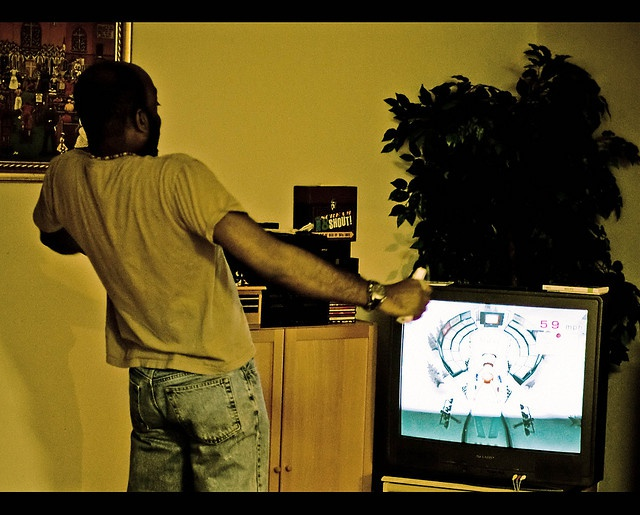Describe the objects in this image and their specific colors. I can see people in black and olive tones, tv in black, white, teal, and lightblue tones, and remote in black, tan, khaki, and olive tones in this image. 